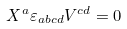<formula> <loc_0><loc_0><loc_500><loc_500>X ^ { a } \varepsilon _ { a b c d } V ^ { c d } = 0</formula> 